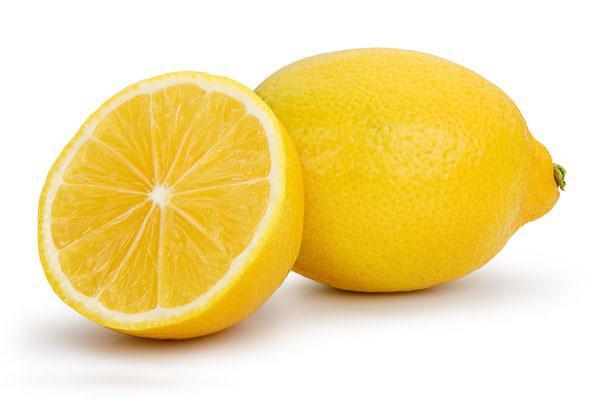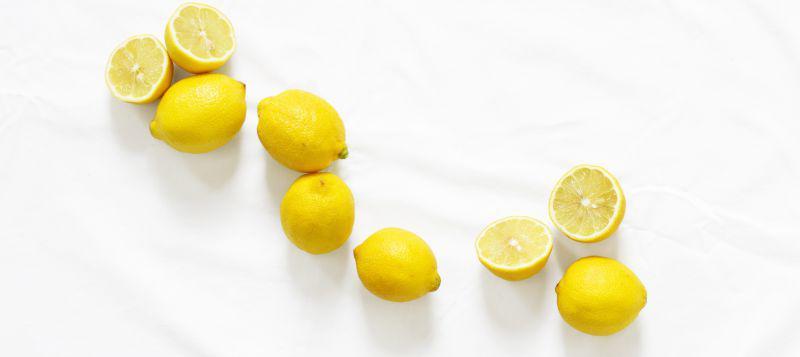The first image is the image on the left, the second image is the image on the right. For the images displayed, is the sentence "In at least one image there is at least one image with a full lemon and a lemon half cut horizontal." factually correct? Answer yes or no. Yes. The first image is the image on the left, the second image is the image on the right. Examine the images to the left and right. Is the description "Each image includes at least one whole lemon and one half lemon." accurate? Answer yes or no. Yes. 